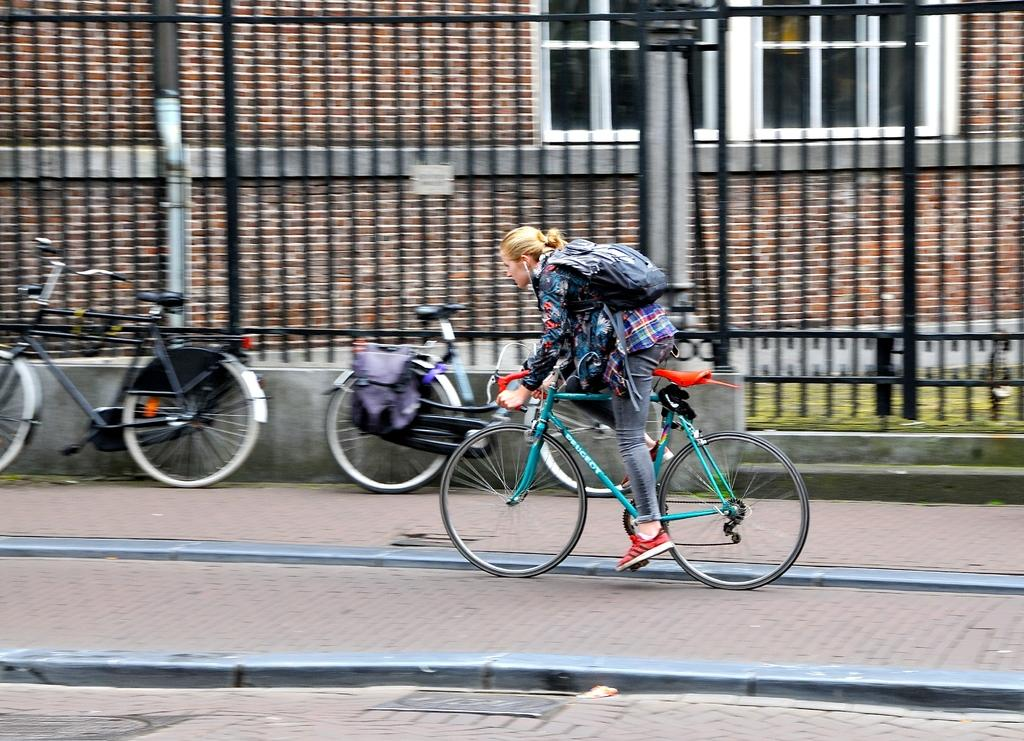What is the woman in the image doing? The woman is riding a cycle in the image. What is the woman wearing while riding the cycle? The woman is wearing a bag. Where is the woman riding the cycle? The woman is riding the cycle on a sidewalk. What can be seen in the background of the image? There are railings, buildings, and windows visible in the background. How many cycles are parked near the railings? Two cycles are parked near the railings. What is the birth date of the woman riding the cycle in the image? There is no information about the woman's birth date in the image. Does the woman have any fangs visible while riding the cycle? There are no fangs visible on the woman in the image. 